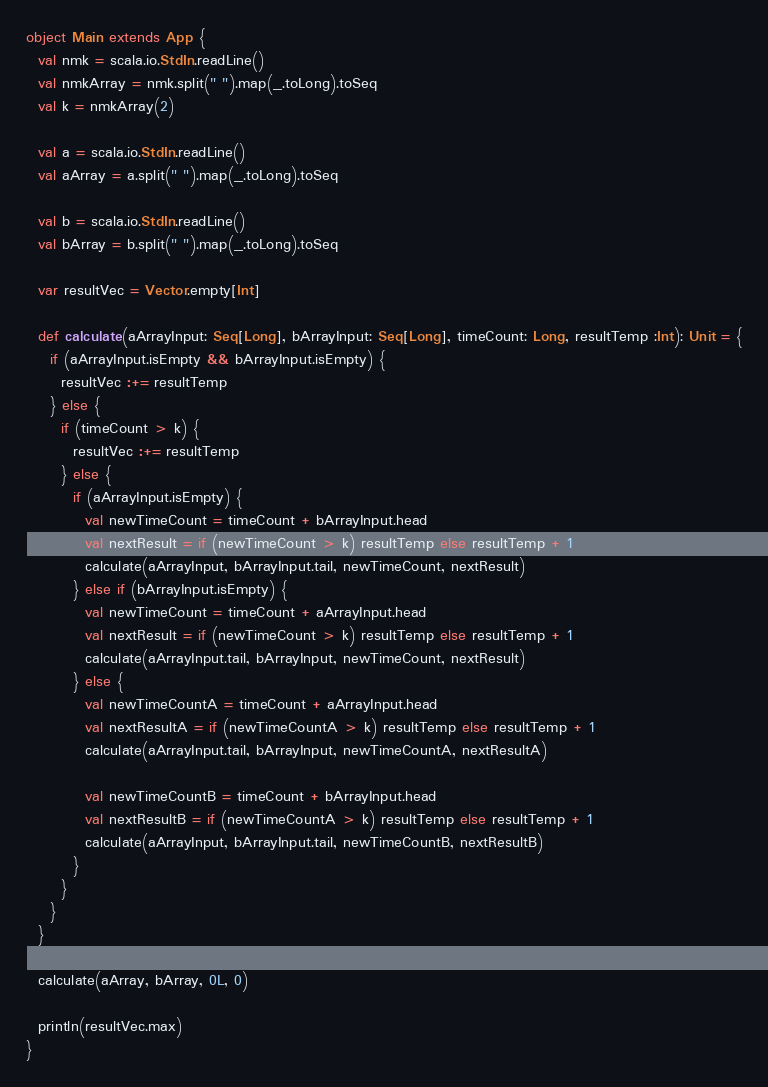Convert code to text. <code><loc_0><loc_0><loc_500><loc_500><_Scala_>object Main extends App {
  val nmk = scala.io.StdIn.readLine()
  val nmkArray = nmk.split(" ").map(_.toLong).toSeq
  val k = nmkArray(2)

  val a = scala.io.StdIn.readLine()
  val aArray = a.split(" ").map(_.toLong).toSeq

  val b = scala.io.StdIn.readLine()
  val bArray = b.split(" ").map(_.toLong).toSeq

  var resultVec = Vector.empty[Int]

  def calculate(aArrayInput: Seq[Long], bArrayInput: Seq[Long], timeCount: Long, resultTemp :Int): Unit = {
    if (aArrayInput.isEmpty && bArrayInput.isEmpty) {
      resultVec :+= resultTemp
    } else {
      if (timeCount > k) {
        resultVec :+= resultTemp
      } else {
        if (aArrayInput.isEmpty) {
          val newTimeCount = timeCount + bArrayInput.head
          val nextResult = if (newTimeCount > k) resultTemp else resultTemp + 1
          calculate(aArrayInput, bArrayInput.tail, newTimeCount, nextResult)
        } else if (bArrayInput.isEmpty) {
          val newTimeCount = timeCount + aArrayInput.head
          val nextResult = if (newTimeCount > k) resultTemp else resultTemp + 1
          calculate(aArrayInput.tail, bArrayInput, newTimeCount, nextResult)
        } else {
          val newTimeCountA = timeCount + aArrayInput.head
          val nextResultA = if (newTimeCountA > k) resultTemp else resultTemp + 1
          calculate(aArrayInput.tail, bArrayInput, newTimeCountA, nextResultA)

          val newTimeCountB = timeCount + bArrayInput.head
          val nextResultB = if (newTimeCountA > k) resultTemp else resultTemp + 1
          calculate(aArrayInput, bArrayInput.tail, newTimeCountB, nextResultB)
        }
      }
    }
  }

  calculate(aArray, bArray, 0L, 0)

  println(resultVec.max)
}</code> 